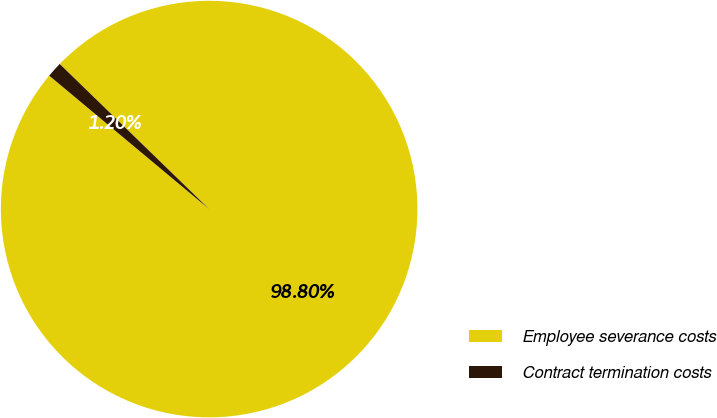Convert chart. <chart><loc_0><loc_0><loc_500><loc_500><pie_chart><fcel>Employee severance costs<fcel>Contract termination costs<nl><fcel>98.8%<fcel>1.2%<nl></chart> 